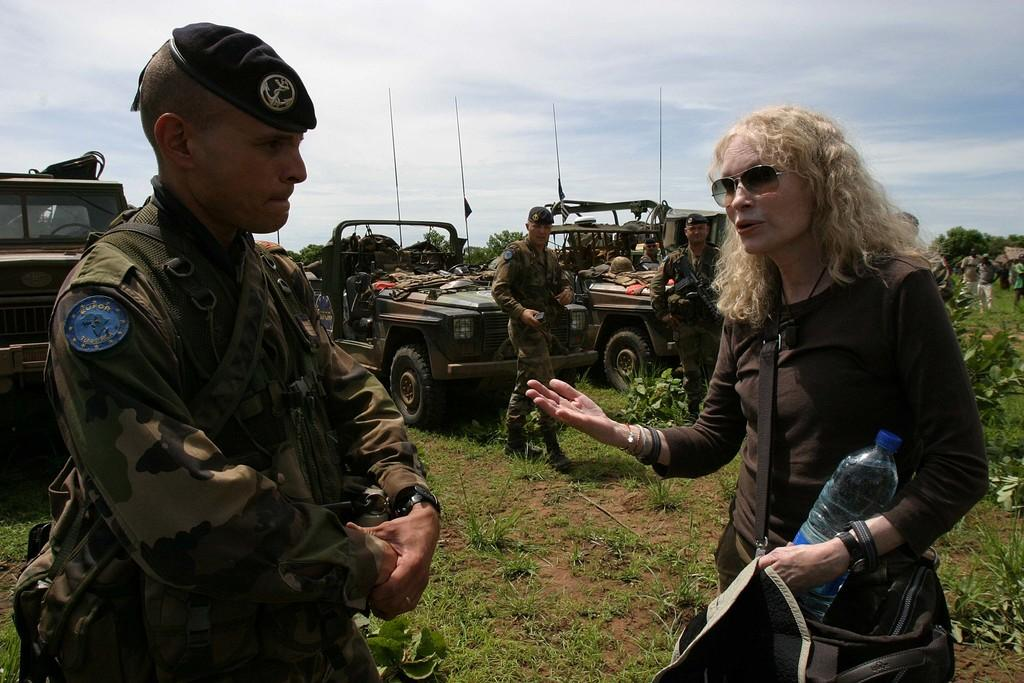What is the main subject in the foreground of the image? There is a man and a woman in the foreground of the image. What type of terrain is visible in the foreground? There is grass in the foreground of the image. What can be seen in the middle of the image? There are vehicles, people, plants, and other objects in the middle of the image. What is visible at the top of the image? The sky is visible at the top of the image. How many horses are present in the image? There are no horses present in the image. What type of porter is assisting the people in the image? There is no porter present in the image, and therefore no assistance can be observed. 